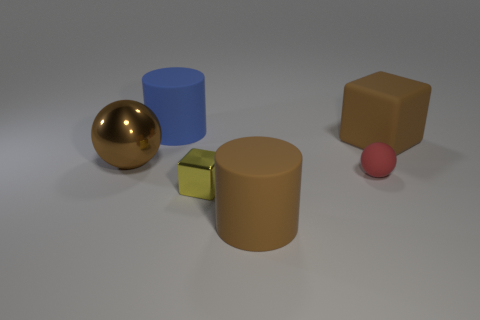Is the number of large cubes that are in front of the brown matte cylinder less than the number of big green things?
Your answer should be compact. No. There is a tiny red sphere on the left side of the big cube; what is its material?
Provide a short and direct response. Rubber. How many other objects are there of the same size as the brown shiny object?
Give a very brief answer. 3. Is the size of the brown block the same as the sphere that is to the left of the big blue rubber cylinder?
Keep it short and to the point. Yes. The big matte thing that is in front of the metallic thing that is left of the matte cylinder that is behind the big rubber cube is what shape?
Your response must be concise. Cylinder. Are there fewer small yellow things than small red metallic cylinders?
Your answer should be very brief. No. Are there any objects on the left side of the red sphere?
Your answer should be compact. Yes. The object that is to the left of the yellow metal block and in front of the large blue rubber cylinder has what shape?
Your response must be concise. Sphere. Are there any small metallic things of the same shape as the tiny red matte object?
Keep it short and to the point. No. There is a matte cylinder that is in front of the brown matte block; is its size the same as the ball to the left of the blue cylinder?
Provide a succinct answer. Yes. 